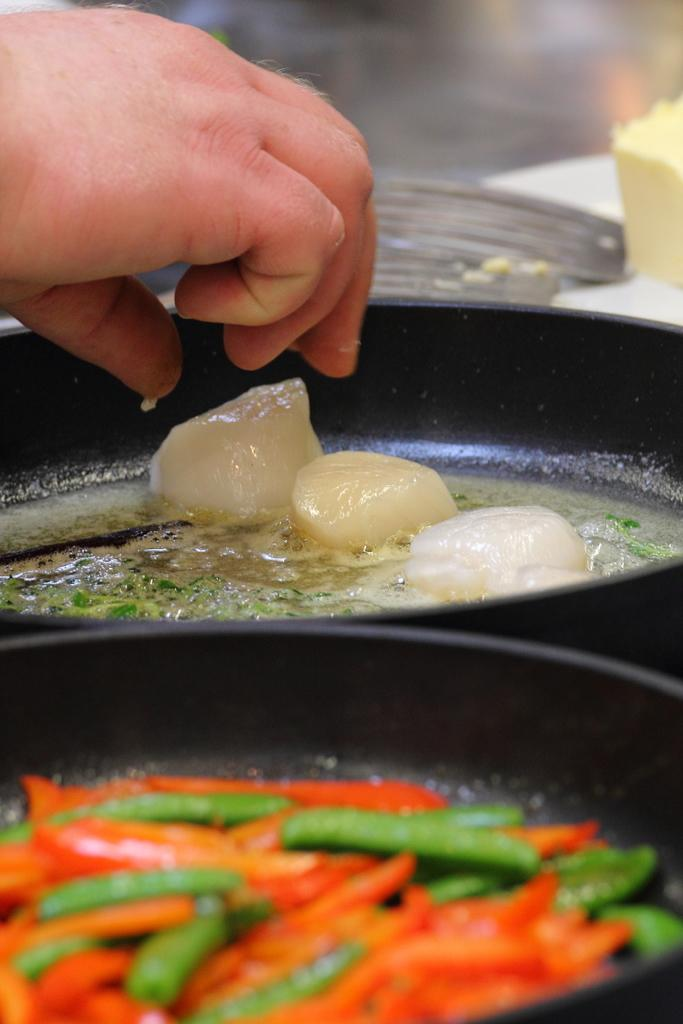What is being cooked in the pan in the image? There are food items in a pan in the image. Whose hand is visible in the image? A person's hand is visible in the image. What is present on the table in the image? There is butter on the table in the image. How many kittens are playing with the butter in the image? There are no kittens present in the image; it only shows food items in a pan, a person's hand, and butter on the table. 